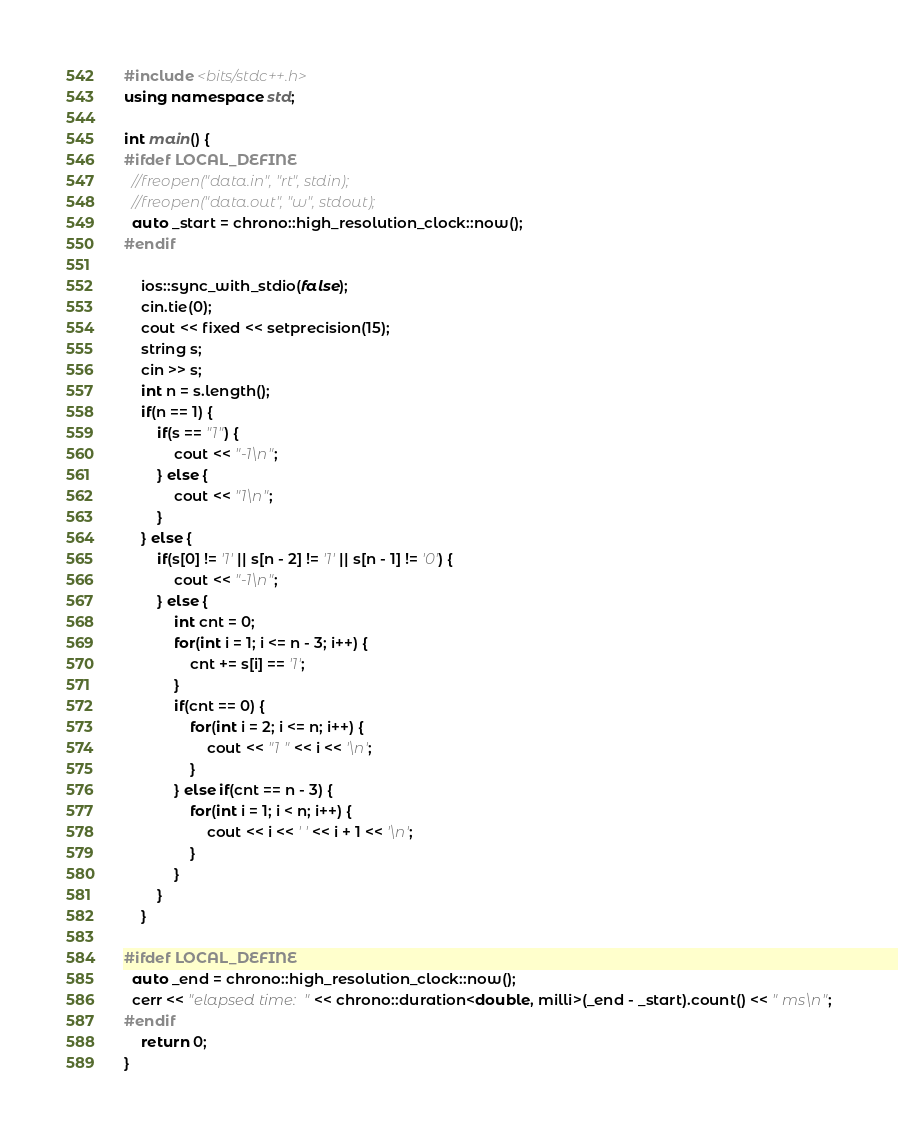<code> <loc_0><loc_0><loc_500><loc_500><_C++_>#include <bits/stdc++.h>
using namespace std;

int main() {
#ifdef LOCAL_DEFINE
  //freopen("data.in", "rt", stdin);
  //freopen("data.out", "w", stdout);
  auto _start = chrono::high_resolution_clock::now();
#endif
	
	ios::sync_with_stdio(false);
	cin.tie(0);
	cout << fixed << setprecision(15);
	string s;
	cin >> s;
	int n = s.length();
	if(n == 1) {
		if(s == "1") {
			cout << "-1\n";
		} else {
			cout << "1\n";
		}
	} else {
		if(s[0] != '1' || s[n - 2] != '1' || s[n - 1] != '0') {
			cout << "-1\n";
		} else {
			int cnt = 0;
			for(int i = 1; i <= n - 3; i++) {
				cnt += s[i] == '1';
			}
			if(cnt == 0) {
				for(int i = 2; i <= n; i++) {
					cout << "1 " << i << '\n';
				}
			} else if(cnt == n - 3) {
				for(int i = 1; i < n; i++) {
					cout << i << ' ' << i + 1 << '\n';
				}
			}
		}
	}

#ifdef LOCAL_DEFINE
  auto _end = chrono::high_resolution_clock::now();
  cerr << "elapsed time: " << chrono::duration<double, milli>(_end - _start).count() << " ms\n";
#endif
	return 0;
}</code> 